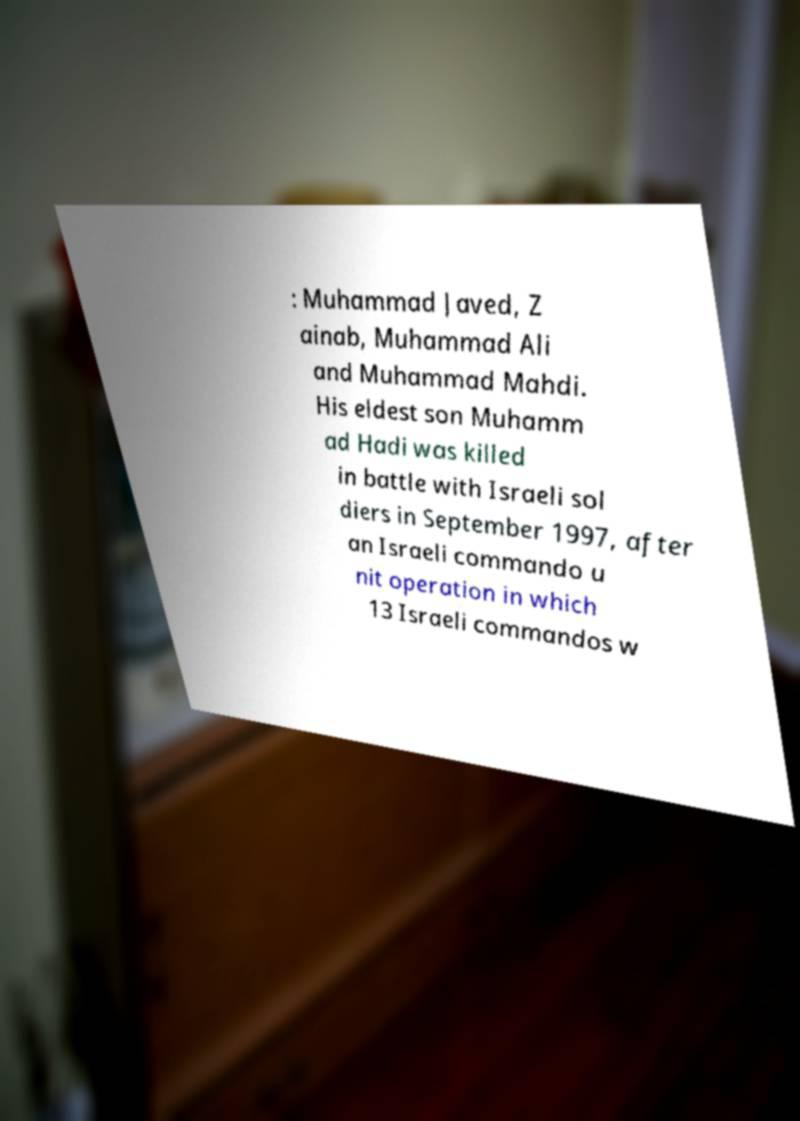Please identify and transcribe the text found in this image. : Muhammad Javed, Z ainab, Muhammad Ali and Muhammad Mahdi. His eldest son Muhamm ad Hadi was killed in battle with Israeli sol diers in September 1997, after an Israeli commando u nit operation in which 13 Israeli commandos w 